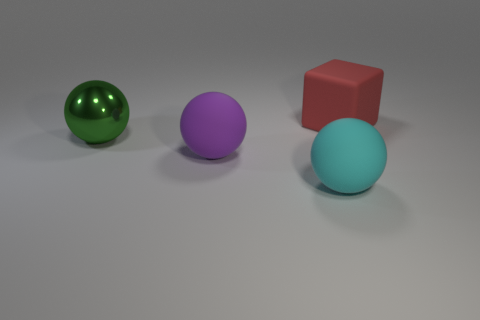Add 1 small brown metallic cylinders. How many objects exist? 5 Subtract all blocks. How many objects are left? 3 Add 1 big brown blocks. How many big brown blocks exist? 1 Subtract 0 yellow cubes. How many objects are left? 4 Subtract all green spheres. Subtract all purple matte spheres. How many objects are left? 2 Add 1 big purple rubber objects. How many big purple rubber objects are left? 2 